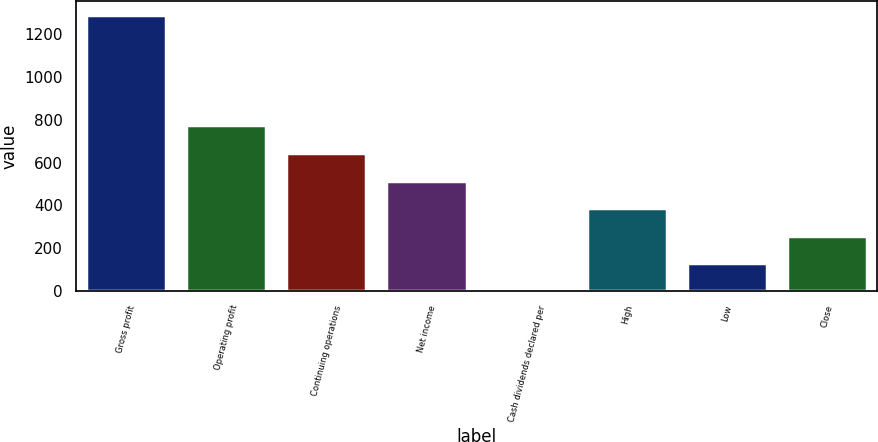Convert chart. <chart><loc_0><loc_0><loc_500><loc_500><bar_chart><fcel>Gross profit<fcel>Operating profit<fcel>Continuing operations<fcel>Net income<fcel>Cash dividends declared per<fcel>High<fcel>Low<fcel>Close<nl><fcel>1289.6<fcel>773.92<fcel>645.01<fcel>516.1<fcel>0.45<fcel>387.18<fcel>129.36<fcel>258.27<nl></chart> 